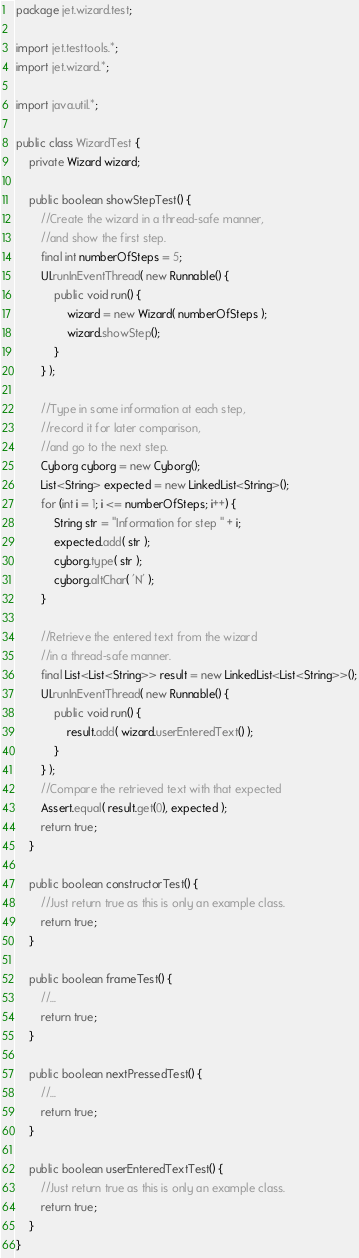<code> <loc_0><loc_0><loc_500><loc_500><_Java_>package jet.wizard.test;

import jet.testtools.*;
import jet.wizard.*;

import java.util.*;

public class WizardTest {
    private Wizard wizard;

    public boolean showStepTest() {
        //Create the wizard in a thread-safe manner,
        //and show the first step.
        final int numberOfSteps = 5;
        UI.runInEventThread( new Runnable() {
            public void run() {
                wizard = new Wizard( numberOfSteps );
                wizard.showStep();
            }
        } );

        //Type in some information at each step,
        //record it for later comparison,
        //and go to the next step.
        Cyborg cyborg = new Cyborg();
        List<String> expected = new LinkedList<String>();
        for (int i = 1; i <= numberOfSteps; i++) {
            String str = "Information for step " + i;
            expected.add( str );
            cyborg.type( str );
            cyborg.altChar( 'N' );
        }

        //Retrieve the entered text from the wizard
        //in a thread-safe manner.
        final List<List<String>> result = new LinkedList<List<String>>();
        UI.runInEventThread( new Runnable() {
            public void run() {
                result.add( wizard.userEnteredText() );
            }
        } );
        //Compare the retrieved text with that expected
        Assert.equal( result.get(0), expected );
        return true;
    }

    public boolean constructorTest() {
        //Just return true as this is only an example class.
        return true;
    }

    public boolean frameTest() {
        //...
        return true;
    }

    public boolean nextPressedTest() {
        //...
        return true;
    }

    public boolean userEnteredTextTest() {
        //Just return true as this is only an example class.
        return true;
    }
}
</code> 